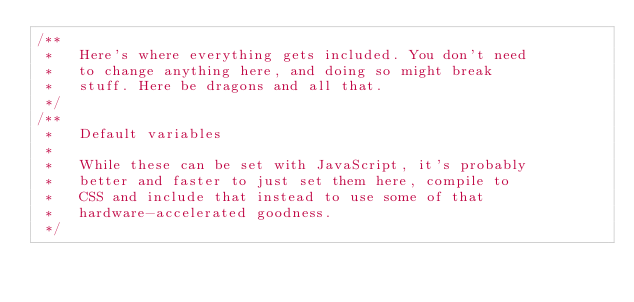<code> <loc_0><loc_0><loc_500><loc_500><_CSS_>/**
 *   Here's where everything gets included. You don't need
 *   to change anything here, and doing so might break
 *   stuff. Here be dragons and all that.
 */
/**
 *   Default variables
 *
 *   While these can be set with JavaScript, it's probably
 *   better and faster to just set them here, compile to
 *   CSS and include that instead to use some of that
 *   hardware-accelerated goodness.
 */</code> 